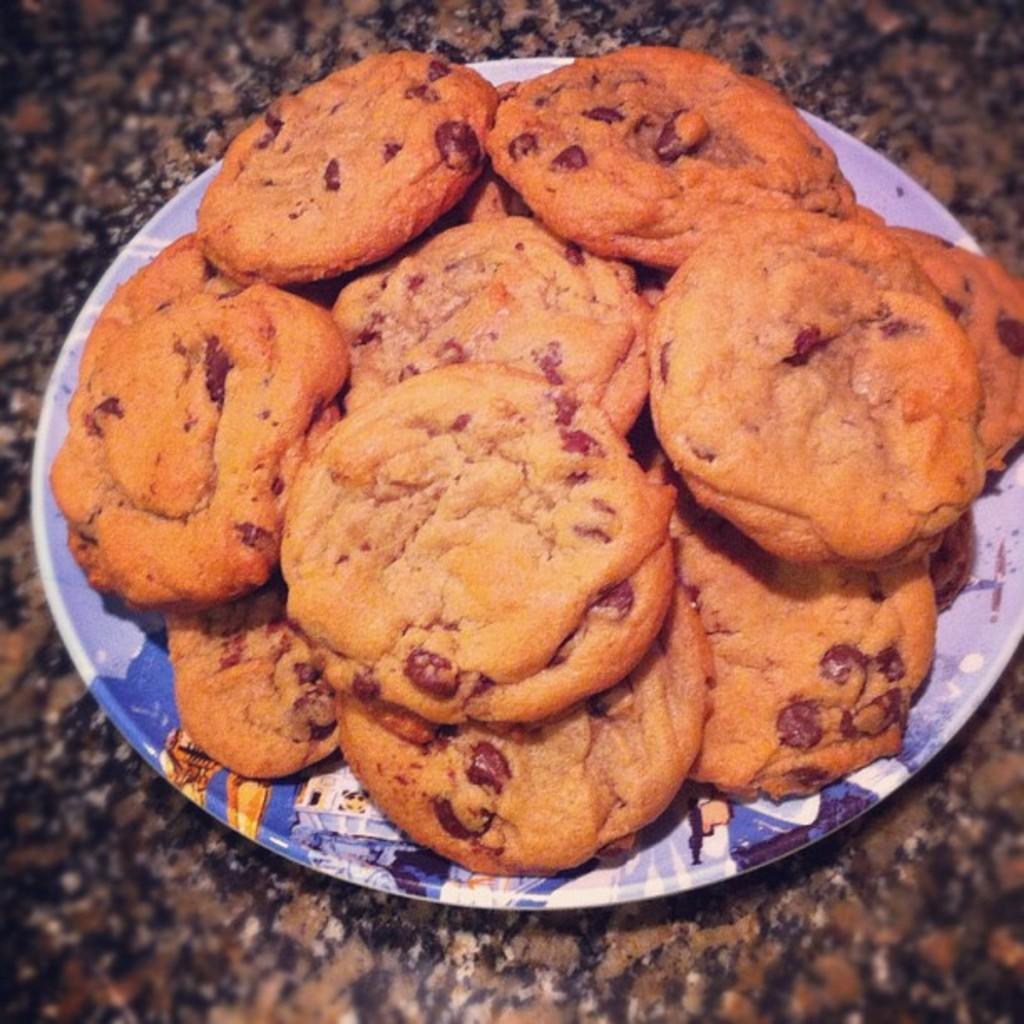How would you summarize this image in a sentence or two? In this image we can see cookies in a plate on the platform. 